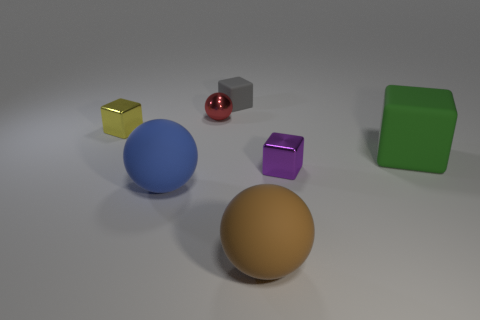Do the big thing that is behind the blue matte thing and the small metal sphere have the same color?
Provide a short and direct response. No. There is a tiny metal thing that is both behind the green cube and right of the big blue ball; what color is it?
Your answer should be compact. Red. There is a purple metallic thing that is the same size as the red ball; what shape is it?
Your answer should be compact. Cube. Are there any yellow metallic things that have the same shape as the tiny red shiny object?
Provide a succinct answer. No. There is a ball that is behind the yellow metallic thing; is it the same size as the tiny yellow metal object?
Offer a terse response. Yes. How big is the rubber object that is in front of the green object and on the left side of the brown ball?
Make the answer very short. Large. How many other objects are the same material as the gray block?
Give a very brief answer. 3. What is the size of the block behind the small red sphere?
Make the answer very short. Small. Do the tiny rubber object and the large matte block have the same color?
Keep it short and to the point. No. How many small things are gray blocks or green things?
Your response must be concise. 1. 